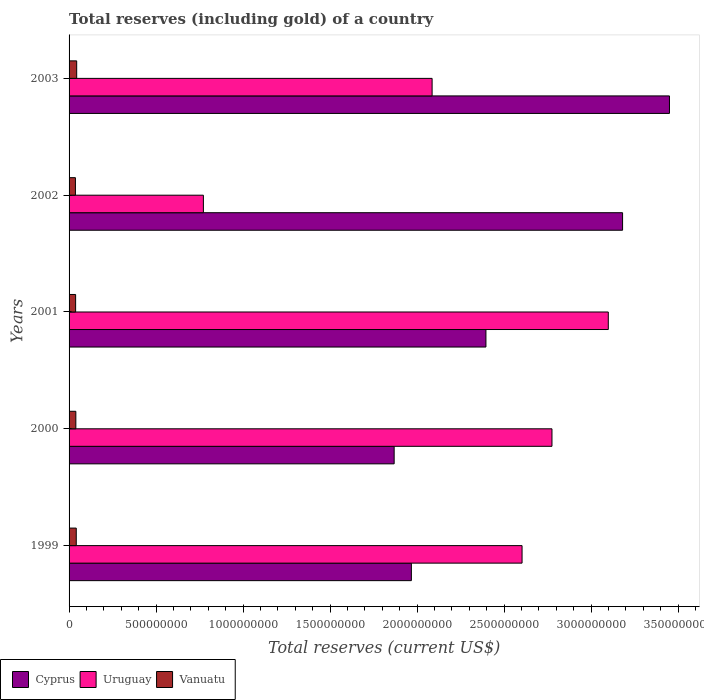How many different coloured bars are there?
Offer a very short reply. 3. Are the number of bars on each tick of the Y-axis equal?
Keep it short and to the point. Yes. How many bars are there on the 2nd tick from the top?
Your response must be concise. 3. What is the label of the 1st group of bars from the top?
Your answer should be compact. 2003. In how many cases, is the number of bars for a given year not equal to the number of legend labels?
Offer a terse response. 0. What is the total reserves (including gold) in Cyprus in 1999?
Ensure brevity in your answer.  1.97e+09. Across all years, what is the maximum total reserves (including gold) in Cyprus?
Offer a very short reply. 3.45e+09. Across all years, what is the minimum total reserves (including gold) in Vanuatu?
Offer a very short reply. 3.65e+07. In which year was the total reserves (including gold) in Cyprus minimum?
Provide a succinct answer. 2000. What is the total total reserves (including gold) in Cyprus in the graph?
Provide a short and direct response. 1.29e+1. What is the difference between the total reserves (including gold) in Cyprus in 2000 and that in 2001?
Ensure brevity in your answer.  -5.28e+08. What is the difference between the total reserves (including gold) in Vanuatu in 1999 and the total reserves (including gold) in Cyprus in 2003?
Keep it short and to the point. -3.41e+09. What is the average total reserves (including gold) in Cyprus per year?
Provide a succinct answer. 2.57e+09. In the year 1999, what is the difference between the total reserves (including gold) in Uruguay and total reserves (including gold) in Cyprus?
Provide a short and direct response. 6.36e+08. What is the ratio of the total reserves (including gold) in Cyprus in 1999 to that in 2000?
Keep it short and to the point. 1.05. Is the total reserves (including gold) in Cyprus in 2002 less than that in 2003?
Your response must be concise. Yes. What is the difference between the highest and the second highest total reserves (including gold) in Vanuatu?
Your answer should be compact. 2.46e+06. What is the difference between the highest and the lowest total reserves (including gold) in Vanuatu?
Your answer should be compact. 7.29e+06. In how many years, is the total reserves (including gold) in Uruguay greater than the average total reserves (including gold) in Uruguay taken over all years?
Provide a succinct answer. 3. Is the sum of the total reserves (including gold) in Vanuatu in 1999 and 2003 greater than the maximum total reserves (including gold) in Cyprus across all years?
Offer a terse response. No. What does the 3rd bar from the top in 2001 represents?
Keep it short and to the point. Cyprus. What does the 3rd bar from the bottom in 2000 represents?
Offer a very short reply. Vanuatu. Is it the case that in every year, the sum of the total reserves (including gold) in Cyprus and total reserves (including gold) in Uruguay is greater than the total reserves (including gold) in Vanuatu?
Your response must be concise. Yes. How many bars are there?
Make the answer very short. 15. Are all the bars in the graph horizontal?
Provide a succinct answer. Yes. How many years are there in the graph?
Your response must be concise. 5. What is the difference between two consecutive major ticks on the X-axis?
Make the answer very short. 5.00e+08. Are the values on the major ticks of X-axis written in scientific E-notation?
Provide a short and direct response. No. Does the graph contain any zero values?
Offer a very short reply. No. Does the graph contain grids?
Give a very brief answer. No. How are the legend labels stacked?
Your response must be concise. Horizontal. What is the title of the graph?
Your answer should be compact. Total reserves (including gold) of a country. What is the label or title of the X-axis?
Your answer should be very brief. Total reserves (current US$). What is the label or title of the Y-axis?
Your answer should be very brief. Years. What is the Total reserves (current US$) of Cyprus in 1999?
Your answer should be very brief. 1.97e+09. What is the Total reserves (current US$) of Uruguay in 1999?
Provide a succinct answer. 2.60e+09. What is the Total reserves (current US$) of Vanuatu in 1999?
Your answer should be compact. 4.14e+07. What is the Total reserves (current US$) in Cyprus in 2000?
Make the answer very short. 1.87e+09. What is the Total reserves (current US$) of Uruguay in 2000?
Offer a terse response. 2.78e+09. What is the Total reserves (current US$) in Vanuatu in 2000?
Offer a very short reply. 3.89e+07. What is the Total reserves (current US$) in Cyprus in 2001?
Offer a very short reply. 2.40e+09. What is the Total reserves (current US$) in Uruguay in 2001?
Your answer should be very brief. 3.10e+09. What is the Total reserves (current US$) in Vanuatu in 2001?
Your response must be concise. 3.77e+07. What is the Total reserves (current US$) in Cyprus in 2002?
Ensure brevity in your answer.  3.18e+09. What is the Total reserves (current US$) in Uruguay in 2002?
Provide a succinct answer. 7.72e+08. What is the Total reserves (current US$) of Vanuatu in 2002?
Make the answer very short. 3.65e+07. What is the Total reserves (current US$) of Cyprus in 2003?
Your response must be concise. 3.45e+09. What is the Total reserves (current US$) in Uruguay in 2003?
Your answer should be very brief. 2.09e+09. What is the Total reserves (current US$) of Vanuatu in 2003?
Your answer should be compact. 4.38e+07. Across all years, what is the maximum Total reserves (current US$) in Cyprus?
Provide a succinct answer. 3.45e+09. Across all years, what is the maximum Total reserves (current US$) in Uruguay?
Provide a succinct answer. 3.10e+09. Across all years, what is the maximum Total reserves (current US$) of Vanuatu?
Your answer should be very brief. 4.38e+07. Across all years, what is the minimum Total reserves (current US$) of Cyprus?
Provide a succinct answer. 1.87e+09. Across all years, what is the minimum Total reserves (current US$) in Uruguay?
Keep it short and to the point. 7.72e+08. Across all years, what is the minimum Total reserves (current US$) in Vanuatu?
Provide a short and direct response. 3.65e+07. What is the total Total reserves (current US$) of Cyprus in the graph?
Your answer should be compact. 1.29e+1. What is the total Total reserves (current US$) of Uruguay in the graph?
Give a very brief answer. 1.13e+1. What is the total Total reserves (current US$) in Vanuatu in the graph?
Provide a succinct answer. 1.98e+08. What is the difference between the Total reserves (current US$) in Cyprus in 1999 and that in 2000?
Your answer should be compact. 9.89e+07. What is the difference between the Total reserves (current US$) in Uruguay in 1999 and that in 2000?
Offer a terse response. -1.72e+08. What is the difference between the Total reserves (current US$) of Vanuatu in 1999 and that in 2000?
Keep it short and to the point. 2.43e+06. What is the difference between the Total reserves (current US$) in Cyprus in 1999 and that in 2001?
Your response must be concise. -4.29e+08. What is the difference between the Total reserves (current US$) in Uruguay in 1999 and that in 2001?
Make the answer very short. -4.96e+08. What is the difference between the Total reserves (current US$) in Vanuatu in 1999 and that in 2001?
Provide a succinct answer. 3.70e+06. What is the difference between the Total reserves (current US$) of Cyprus in 1999 and that in 2002?
Make the answer very short. -1.21e+09. What is the difference between the Total reserves (current US$) in Uruguay in 1999 and that in 2002?
Give a very brief answer. 1.83e+09. What is the difference between the Total reserves (current US$) of Vanuatu in 1999 and that in 2002?
Your answer should be very brief. 4.83e+06. What is the difference between the Total reserves (current US$) in Cyprus in 1999 and that in 2003?
Your answer should be very brief. -1.48e+09. What is the difference between the Total reserves (current US$) of Uruguay in 1999 and that in 2003?
Ensure brevity in your answer.  5.17e+08. What is the difference between the Total reserves (current US$) in Vanuatu in 1999 and that in 2003?
Make the answer very short. -2.46e+06. What is the difference between the Total reserves (current US$) of Cyprus in 2000 and that in 2001?
Your response must be concise. -5.28e+08. What is the difference between the Total reserves (current US$) in Uruguay in 2000 and that in 2001?
Give a very brief answer. -3.24e+08. What is the difference between the Total reserves (current US$) of Vanuatu in 2000 and that in 2001?
Your answer should be compact. 1.26e+06. What is the difference between the Total reserves (current US$) of Cyprus in 2000 and that in 2002?
Offer a very short reply. -1.31e+09. What is the difference between the Total reserves (current US$) of Uruguay in 2000 and that in 2002?
Your answer should be very brief. 2.00e+09. What is the difference between the Total reserves (current US$) in Vanuatu in 2000 and that in 2002?
Ensure brevity in your answer.  2.40e+06. What is the difference between the Total reserves (current US$) in Cyprus in 2000 and that in 2003?
Give a very brief answer. -1.58e+09. What is the difference between the Total reserves (current US$) in Uruguay in 2000 and that in 2003?
Provide a short and direct response. 6.89e+08. What is the difference between the Total reserves (current US$) in Vanuatu in 2000 and that in 2003?
Offer a terse response. -4.89e+06. What is the difference between the Total reserves (current US$) in Cyprus in 2001 and that in 2002?
Offer a very short reply. -7.85e+08. What is the difference between the Total reserves (current US$) of Uruguay in 2001 and that in 2002?
Keep it short and to the point. 2.33e+09. What is the difference between the Total reserves (current US$) of Vanuatu in 2001 and that in 2002?
Your answer should be very brief. 1.14e+06. What is the difference between the Total reserves (current US$) of Cyprus in 2001 and that in 2003?
Your response must be concise. -1.05e+09. What is the difference between the Total reserves (current US$) in Uruguay in 2001 and that in 2003?
Your answer should be very brief. 1.01e+09. What is the difference between the Total reserves (current US$) of Vanuatu in 2001 and that in 2003?
Provide a succinct answer. -6.16e+06. What is the difference between the Total reserves (current US$) of Cyprus in 2002 and that in 2003?
Your response must be concise. -2.70e+08. What is the difference between the Total reserves (current US$) of Uruguay in 2002 and that in 2003?
Your answer should be compact. -1.31e+09. What is the difference between the Total reserves (current US$) of Vanuatu in 2002 and that in 2003?
Your answer should be compact. -7.29e+06. What is the difference between the Total reserves (current US$) in Cyprus in 1999 and the Total reserves (current US$) in Uruguay in 2000?
Offer a very short reply. -8.08e+08. What is the difference between the Total reserves (current US$) in Cyprus in 1999 and the Total reserves (current US$) in Vanuatu in 2000?
Offer a very short reply. 1.93e+09. What is the difference between the Total reserves (current US$) of Uruguay in 1999 and the Total reserves (current US$) of Vanuatu in 2000?
Your response must be concise. 2.56e+09. What is the difference between the Total reserves (current US$) in Cyprus in 1999 and the Total reserves (current US$) in Uruguay in 2001?
Make the answer very short. -1.13e+09. What is the difference between the Total reserves (current US$) in Cyprus in 1999 and the Total reserves (current US$) in Vanuatu in 2001?
Keep it short and to the point. 1.93e+09. What is the difference between the Total reserves (current US$) in Uruguay in 1999 and the Total reserves (current US$) in Vanuatu in 2001?
Ensure brevity in your answer.  2.57e+09. What is the difference between the Total reserves (current US$) in Cyprus in 1999 and the Total reserves (current US$) in Uruguay in 2002?
Provide a short and direct response. 1.20e+09. What is the difference between the Total reserves (current US$) in Cyprus in 1999 and the Total reserves (current US$) in Vanuatu in 2002?
Make the answer very short. 1.93e+09. What is the difference between the Total reserves (current US$) in Uruguay in 1999 and the Total reserves (current US$) in Vanuatu in 2002?
Your response must be concise. 2.57e+09. What is the difference between the Total reserves (current US$) of Cyprus in 1999 and the Total reserves (current US$) of Uruguay in 2003?
Offer a very short reply. -1.19e+08. What is the difference between the Total reserves (current US$) of Cyprus in 1999 and the Total reserves (current US$) of Vanuatu in 2003?
Offer a very short reply. 1.92e+09. What is the difference between the Total reserves (current US$) in Uruguay in 1999 and the Total reserves (current US$) in Vanuatu in 2003?
Offer a terse response. 2.56e+09. What is the difference between the Total reserves (current US$) of Cyprus in 2000 and the Total reserves (current US$) of Uruguay in 2001?
Keep it short and to the point. -1.23e+09. What is the difference between the Total reserves (current US$) of Cyprus in 2000 and the Total reserves (current US$) of Vanuatu in 2001?
Give a very brief answer. 1.83e+09. What is the difference between the Total reserves (current US$) of Uruguay in 2000 and the Total reserves (current US$) of Vanuatu in 2001?
Your response must be concise. 2.74e+09. What is the difference between the Total reserves (current US$) in Cyprus in 2000 and the Total reserves (current US$) in Uruguay in 2002?
Give a very brief answer. 1.10e+09. What is the difference between the Total reserves (current US$) of Cyprus in 2000 and the Total reserves (current US$) of Vanuatu in 2002?
Your response must be concise. 1.83e+09. What is the difference between the Total reserves (current US$) of Uruguay in 2000 and the Total reserves (current US$) of Vanuatu in 2002?
Keep it short and to the point. 2.74e+09. What is the difference between the Total reserves (current US$) of Cyprus in 2000 and the Total reserves (current US$) of Uruguay in 2003?
Give a very brief answer. -2.18e+08. What is the difference between the Total reserves (current US$) of Cyprus in 2000 and the Total reserves (current US$) of Vanuatu in 2003?
Give a very brief answer. 1.82e+09. What is the difference between the Total reserves (current US$) of Uruguay in 2000 and the Total reserves (current US$) of Vanuatu in 2003?
Your response must be concise. 2.73e+09. What is the difference between the Total reserves (current US$) of Cyprus in 2001 and the Total reserves (current US$) of Uruguay in 2002?
Make the answer very short. 1.62e+09. What is the difference between the Total reserves (current US$) in Cyprus in 2001 and the Total reserves (current US$) in Vanuatu in 2002?
Your answer should be compact. 2.36e+09. What is the difference between the Total reserves (current US$) in Uruguay in 2001 and the Total reserves (current US$) in Vanuatu in 2002?
Offer a terse response. 3.06e+09. What is the difference between the Total reserves (current US$) in Cyprus in 2001 and the Total reserves (current US$) in Uruguay in 2003?
Provide a short and direct response. 3.09e+08. What is the difference between the Total reserves (current US$) of Cyprus in 2001 and the Total reserves (current US$) of Vanuatu in 2003?
Ensure brevity in your answer.  2.35e+09. What is the difference between the Total reserves (current US$) in Uruguay in 2001 and the Total reserves (current US$) in Vanuatu in 2003?
Ensure brevity in your answer.  3.06e+09. What is the difference between the Total reserves (current US$) in Cyprus in 2002 and the Total reserves (current US$) in Uruguay in 2003?
Keep it short and to the point. 1.09e+09. What is the difference between the Total reserves (current US$) of Cyprus in 2002 and the Total reserves (current US$) of Vanuatu in 2003?
Give a very brief answer. 3.14e+09. What is the difference between the Total reserves (current US$) in Uruguay in 2002 and the Total reserves (current US$) in Vanuatu in 2003?
Make the answer very short. 7.28e+08. What is the average Total reserves (current US$) of Cyprus per year?
Make the answer very short. 2.57e+09. What is the average Total reserves (current US$) of Uruguay per year?
Offer a very short reply. 2.27e+09. What is the average Total reserves (current US$) of Vanuatu per year?
Your answer should be compact. 3.97e+07. In the year 1999, what is the difference between the Total reserves (current US$) of Cyprus and Total reserves (current US$) of Uruguay?
Make the answer very short. -6.36e+08. In the year 1999, what is the difference between the Total reserves (current US$) of Cyprus and Total reserves (current US$) of Vanuatu?
Provide a succinct answer. 1.93e+09. In the year 1999, what is the difference between the Total reserves (current US$) in Uruguay and Total reserves (current US$) in Vanuatu?
Your response must be concise. 2.56e+09. In the year 2000, what is the difference between the Total reserves (current US$) in Cyprus and Total reserves (current US$) in Uruguay?
Offer a very short reply. -9.07e+08. In the year 2000, what is the difference between the Total reserves (current US$) in Cyprus and Total reserves (current US$) in Vanuatu?
Your response must be concise. 1.83e+09. In the year 2000, what is the difference between the Total reserves (current US$) of Uruguay and Total reserves (current US$) of Vanuatu?
Offer a very short reply. 2.74e+09. In the year 2001, what is the difference between the Total reserves (current US$) of Cyprus and Total reserves (current US$) of Uruguay?
Your answer should be very brief. -7.03e+08. In the year 2001, what is the difference between the Total reserves (current US$) of Cyprus and Total reserves (current US$) of Vanuatu?
Your answer should be very brief. 2.36e+09. In the year 2001, what is the difference between the Total reserves (current US$) in Uruguay and Total reserves (current US$) in Vanuatu?
Your answer should be compact. 3.06e+09. In the year 2002, what is the difference between the Total reserves (current US$) in Cyprus and Total reserves (current US$) in Uruguay?
Provide a short and direct response. 2.41e+09. In the year 2002, what is the difference between the Total reserves (current US$) in Cyprus and Total reserves (current US$) in Vanuatu?
Keep it short and to the point. 3.14e+09. In the year 2002, what is the difference between the Total reserves (current US$) in Uruguay and Total reserves (current US$) in Vanuatu?
Your answer should be very brief. 7.36e+08. In the year 2003, what is the difference between the Total reserves (current US$) of Cyprus and Total reserves (current US$) of Uruguay?
Your answer should be compact. 1.36e+09. In the year 2003, what is the difference between the Total reserves (current US$) of Cyprus and Total reserves (current US$) of Vanuatu?
Your answer should be very brief. 3.41e+09. In the year 2003, what is the difference between the Total reserves (current US$) in Uruguay and Total reserves (current US$) in Vanuatu?
Provide a short and direct response. 2.04e+09. What is the ratio of the Total reserves (current US$) in Cyprus in 1999 to that in 2000?
Ensure brevity in your answer.  1.05. What is the ratio of the Total reserves (current US$) in Uruguay in 1999 to that in 2000?
Your answer should be very brief. 0.94. What is the ratio of the Total reserves (current US$) in Vanuatu in 1999 to that in 2000?
Ensure brevity in your answer.  1.06. What is the ratio of the Total reserves (current US$) in Cyprus in 1999 to that in 2001?
Your answer should be very brief. 0.82. What is the ratio of the Total reserves (current US$) of Uruguay in 1999 to that in 2001?
Ensure brevity in your answer.  0.84. What is the ratio of the Total reserves (current US$) in Vanuatu in 1999 to that in 2001?
Provide a succinct answer. 1.1. What is the ratio of the Total reserves (current US$) of Cyprus in 1999 to that in 2002?
Provide a succinct answer. 0.62. What is the ratio of the Total reserves (current US$) of Uruguay in 1999 to that in 2002?
Offer a terse response. 3.37. What is the ratio of the Total reserves (current US$) in Vanuatu in 1999 to that in 2002?
Your answer should be compact. 1.13. What is the ratio of the Total reserves (current US$) in Cyprus in 1999 to that in 2003?
Keep it short and to the point. 0.57. What is the ratio of the Total reserves (current US$) of Uruguay in 1999 to that in 2003?
Offer a terse response. 1.25. What is the ratio of the Total reserves (current US$) of Vanuatu in 1999 to that in 2003?
Offer a very short reply. 0.94. What is the ratio of the Total reserves (current US$) in Cyprus in 2000 to that in 2001?
Offer a terse response. 0.78. What is the ratio of the Total reserves (current US$) of Uruguay in 2000 to that in 2001?
Provide a succinct answer. 0.9. What is the ratio of the Total reserves (current US$) of Vanuatu in 2000 to that in 2001?
Your answer should be very brief. 1.03. What is the ratio of the Total reserves (current US$) of Cyprus in 2000 to that in 2002?
Give a very brief answer. 0.59. What is the ratio of the Total reserves (current US$) in Uruguay in 2000 to that in 2002?
Make the answer very short. 3.6. What is the ratio of the Total reserves (current US$) of Vanuatu in 2000 to that in 2002?
Your response must be concise. 1.07. What is the ratio of the Total reserves (current US$) of Cyprus in 2000 to that in 2003?
Provide a short and direct response. 0.54. What is the ratio of the Total reserves (current US$) in Uruguay in 2000 to that in 2003?
Offer a very short reply. 1.33. What is the ratio of the Total reserves (current US$) of Vanuatu in 2000 to that in 2003?
Make the answer very short. 0.89. What is the ratio of the Total reserves (current US$) in Cyprus in 2001 to that in 2002?
Ensure brevity in your answer.  0.75. What is the ratio of the Total reserves (current US$) of Uruguay in 2001 to that in 2002?
Make the answer very short. 4.01. What is the ratio of the Total reserves (current US$) in Vanuatu in 2001 to that in 2002?
Provide a short and direct response. 1.03. What is the ratio of the Total reserves (current US$) in Cyprus in 2001 to that in 2003?
Offer a terse response. 0.69. What is the ratio of the Total reserves (current US$) in Uruguay in 2001 to that in 2003?
Your answer should be very brief. 1.49. What is the ratio of the Total reserves (current US$) of Vanuatu in 2001 to that in 2003?
Offer a very short reply. 0.86. What is the ratio of the Total reserves (current US$) in Cyprus in 2002 to that in 2003?
Make the answer very short. 0.92. What is the ratio of the Total reserves (current US$) in Uruguay in 2002 to that in 2003?
Keep it short and to the point. 0.37. What is the ratio of the Total reserves (current US$) in Vanuatu in 2002 to that in 2003?
Provide a short and direct response. 0.83. What is the difference between the highest and the second highest Total reserves (current US$) in Cyprus?
Your answer should be very brief. 2.70e+08. What is the difference between the highest and the second highest Total reserves (current US$) in Uruguay?
Keep it short and to the point. 3.24e+08. What is the difference between the highest and the second highest Total reserves (current US$) of Vanuatu?
Offer a very short reply. 2.46e+06. What is the difference between the highest and the lowest Total reserves (current US$) of Cyprus?
Offer a terse response. 1.58e+09. What is the difference between the highest and the lowest Total reserves (current US$) in Uruguay?
Offer a terse response. 2.33e+09. What is the difference between the highest and the lowest Total reserves (current US$) in Vanuatu?
Ensure brevity in your answer.  7.29e+06. 